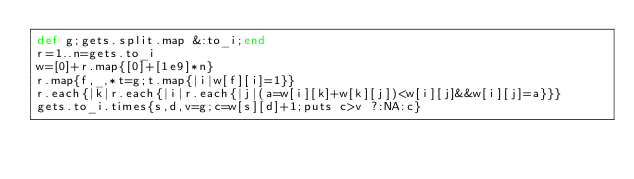<code> <loc_0><loc_0><loc_500><loc_500><_Ruby_>def g;gets.split.map &:to_i;end
r=1..n=gets.to_i
w=[0]+r.map{[0]+[1e9]*n}
r.map{f,_,*t=g;t.map{|i|w[f][i]=1}}
r.each{|k|r.each{|i|r.each{|j|(a=w[i][k]+w[k][j])<w[i][j]&&w[i][j]=a}}}
gets.to_i.times{s,d,v=g;c=w[s][d]+1;puts c>v ?:NA:c}</code> 